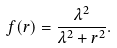<formula> <loc_0><loc_0><loc_500><loc_500>f ( r ) = \frac { \lambda ^ { 2 } } { \lambda ^ { 2 } + r ^ { 2 } } .</formula> 